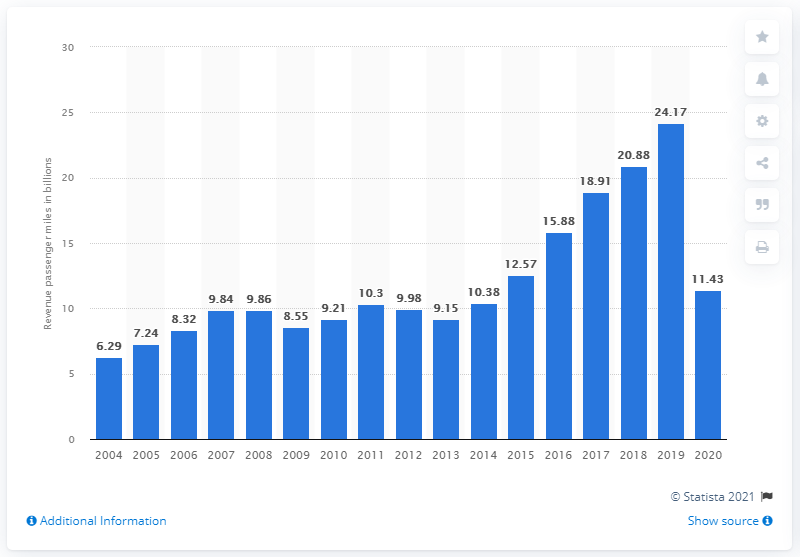Give some essential details in this illustration. In 2020, Frontier Airlines transported a total of 11,430,000 passenger miles. 